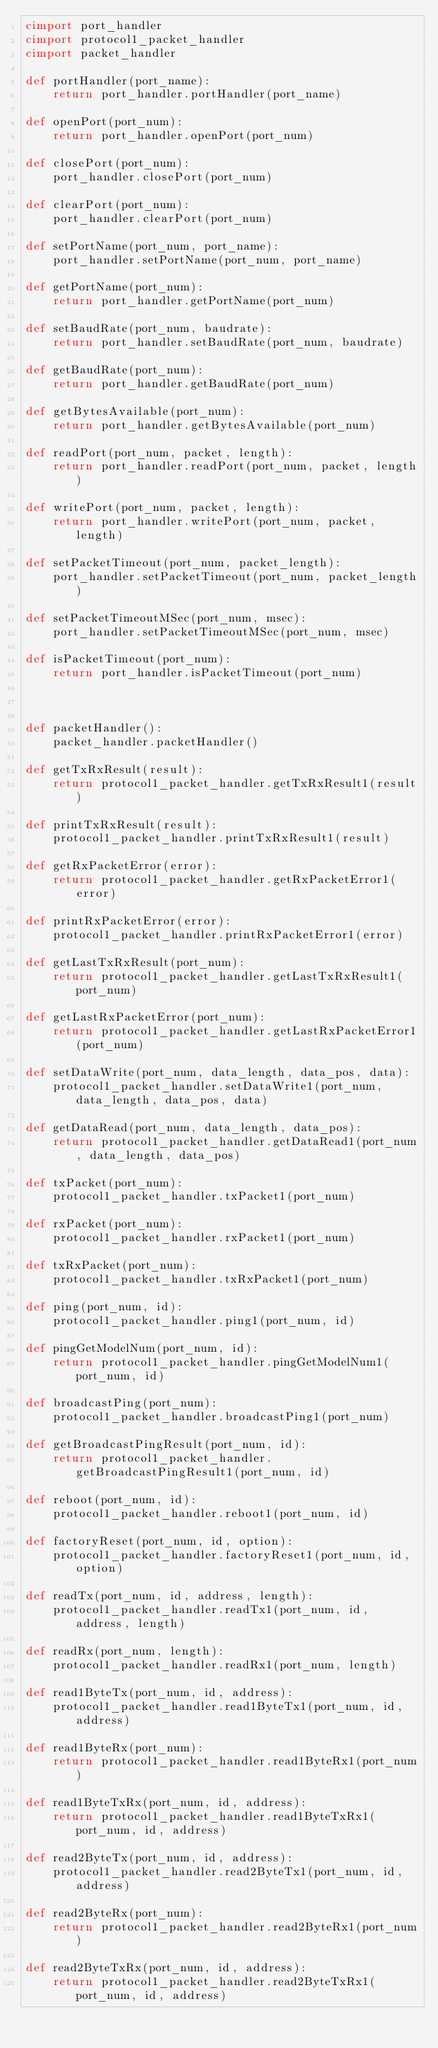<code> <loc_0><loc_0><loc_500><loc_500><_Cython_>cimport port_handler
cimport protocol1_packet_handler
cimport packet_handler

def portHandler(port_name):
    return port_handler.portHandler(port_name)

def openPort(port_num):
    return port_handler.openPort(port_num)

def closePort(port_num):
    port_handler.closePort(port_num)

def clearPort(port_num):
    port_handler.clearPort(port_num)

def setPortName(port_num, port_name):
    port_handler.setPortName(port_num, port_name)

def getPortName(port_num):
    return port_handler.getPortName(port_num)

def setBaudRate(port_num, baudrate):
    return port_handler.setBaudRate(port_num, baudrate)

def getBaudRate(port_num):
    return port_handler.getBaudRate(port_num)

def getBytesAvailable(port_num):
    return port_handler.getBytesAvailable(port_num)

def readPort(port_num, packet, length):
    return port_handler.readPort(port_num, packet, length)

def writePort(port_num, packet, length):
    return port_handler.writePort(port_num, packet, length)

def setPacketTimeout(port_num, packet_length):
    port_handler.setPacketTimeout(port_num, packet_length)

def setPacketTimeoutMSec(port_num, msec):
    port_handler.setPacketTimeoutMSec(port_num, msec)

def isPacketTimeout(port_num):
    return port_handler.isPacketTimeout(port_num)



def packetHandler():
    packet_handler.packetHandler()

def getTxRxResult(result):
    return protocol1_packet_handler.getTxRxResult1(result)

def printTxRxResult(result):
    protocol1_packet_handler.printTxRxResult1(result)

def getRxPacketError(error):
    return protocol1_packet_handler.getRxPacketError1(error)

def printRxPacketError(error):
    protocol1_packet_handler.printRxPacketError1(error)

def getLastTxRxResult(port_num):
    return protocol1_packet_handler.getLastTxRxResult1(port_num)

def getLastRxPacketError(port_num):
    return protocol1_packet_handler.getLastRxPacketError1(port_num)

def setDataWrite(port_num, data_length, data_pos, data):
    protocol1_packet_handler.setDataWrite1(port_num, data_length, data_pos, data)

def getDataRead(port_num, data_length, data_pos):
    return protocol1_packet_handler.getDataRead1(port_num, data_length, data_pos)

def txPacket(port_num):
    protocol1_packet_handler.txPacket1(port_num)

def rxPacket(port_num):
    protocol1_packet_handler.rxPacket1(port_num)

def txRxPacket(port_num):
    protocol1_packet_handler.txRxPacket1(port_num)

def ping(port_num, id):
    protocol1_packet_handler.ping1(port_num, id)

def pingGetModelNum(port_num, id):
    return protocol1_packet_handler.pingGetModelNum1(port_num, id)

def broadcastPing(port_num):
    protocol1_packet_handler.broadcastPing1(port_num)

def getBroadcastPingResult(port_num, id):
    return protocol1_packet_handler.getBroadcastPingResult1(port_num, id)

def reboot(port_num, id):
    protocol1_packet_handler.reboot1(port_num, id)

def factoryReset(port_num, id, option):
    protocol1_packet_handler.factoryReset1(port_num, id, option)

def readTx(port_num, id, address, length):
    protocol1_packet_handler.readTx1(port_num, id, address, length)

def readRx(port_num, length):
    protocol1_packet_handler.readRx1(port_num, length)

def read1ByteTx(port_num, id, address):
    protocol1_packet_handler.read1ByteTx1(port_num, id, address)

def read1ByteRx(port_num):
    return protocol1_packet_handler.read1ByteRx1(port_num)

def read1ByteTxRx(port_num, id, address):
    return protocol1_packet_handler.read1ByteTxRx1(port_num, id, address)

def read2ByteTx(port_num, id, address):
    protocol1_packet_handler.read2ByteTx1(port_num, id, address)

def read2ByteRx(port_num):
    return protocol1_packet_handler.read2ByteRx1(port_num)

def read2ByteTxRx(port_num, id, address):
    return protocol1_packet_handler.read2ByteTxRx1(port_num, id, address)
</code> 